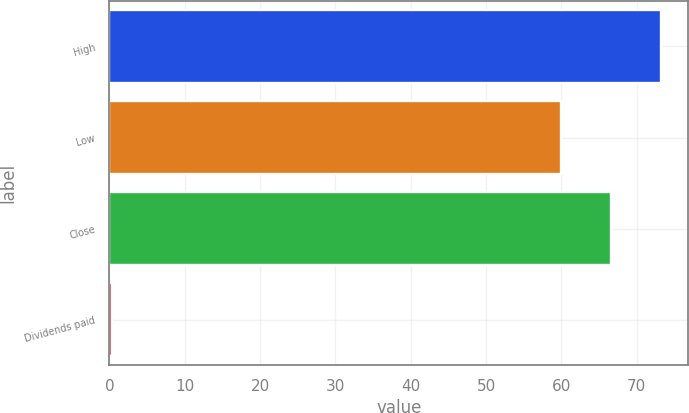<chart> <loc_0><loc_0><loc_500><loc_500><bar_chart><fcel>High<fcel>Low<fcel>Close<fcel>Dividends paid<nl><fcel>73.16<fcel>59.92<fcel>66.54<fcel>0.32<nl></chart> 